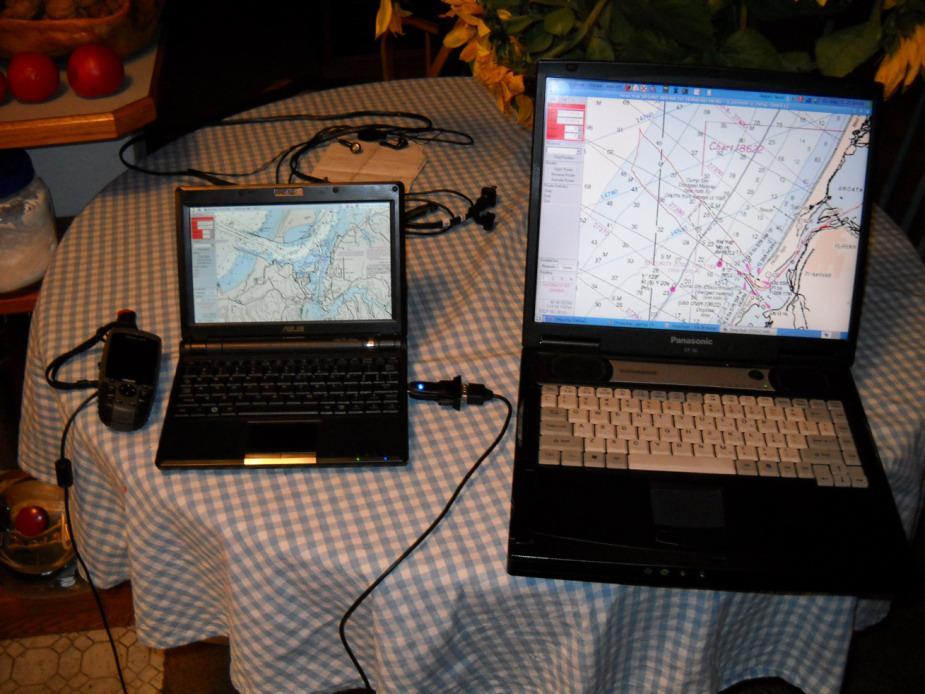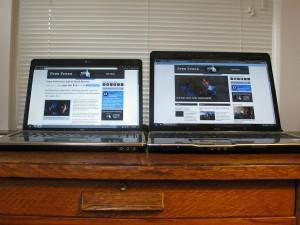The first image is the image on the left, the second image is the image on the right. Given the left and right images, does the statement "Both of the tables under the computers have straight edges." hold true? Answer yes or no. No. The first image is the image on the left, the second image is the image on the right. For the images shown, is this caption "The left image shows exactly two open screen devices, one distinctly smaller than the other and positioned next to it on a table." true? Answer yes or no. Yes. 